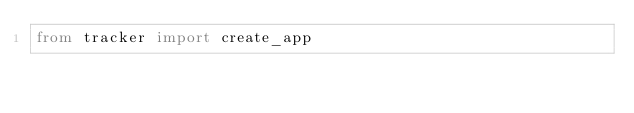<code> <loc_0><loc_0><loc_500><loc_500><_Python_>from tracker import create_app

</code> 